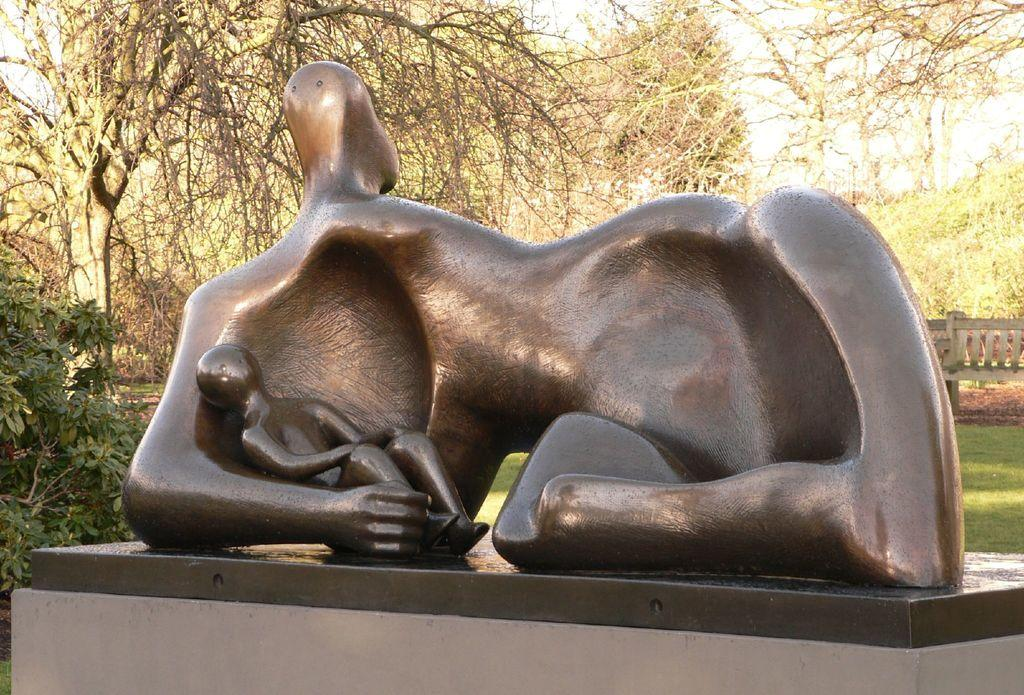What is the main subject in the foreground of the picture? There is a sculpture in the foreground of the picture. What can be seen on the left side of the picture? There are trees on the left side of the picture. What is visible in the background of the picture? There are trees, grass, a plant, and the sky visible in the background of the picture. What architectural feature can be seen on the right side of the picture? There is a bridge on the right side of the picture. What type of breakfast is being served on the bridge in the image? There is no breakfast or any indication of food being served in the image; the focus is on the sculpture, trees, grass, plant, and bridge. 